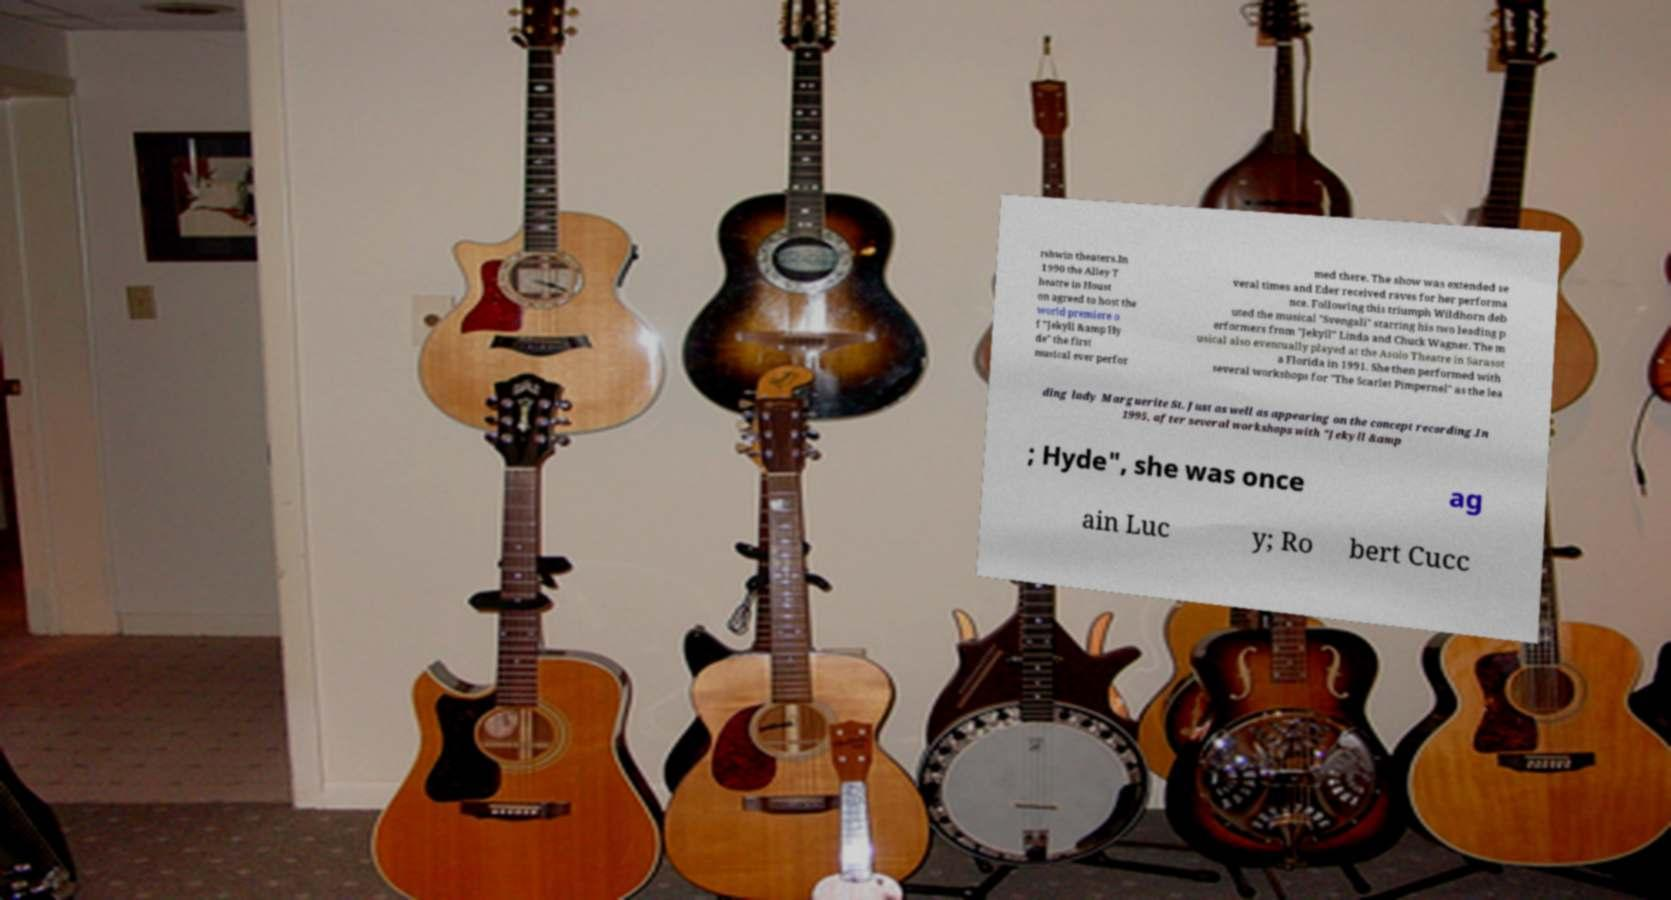Can you accurately transcribe the text from the provided image for me? rshwin theaters.In 1990 the Alley T heatre in Houst on agreed to host the world premiere o f "Jekyll &amp Hy de" the first musical ever perfor med there. The show was extended se veral times and Eder received raves for her performa nce. Following this triumph Wildhorn deb uted the musical "Svengali" starring his two leading p erformers from "Jekyll" Linda and Chuck Wagner. The m usical also eventually played at the Asolo Theatre in Sarasot a Florida in 1991. She then performed with several workshops for "The Scarlet Pimpernel" as the lea ding lady Marguerite St. Just as well as appearing on the concept recording.In 1995, after several workshops with "Jekyll &amp ; Hyde", she was once ag ain Luc y; Ro bert Cucc 